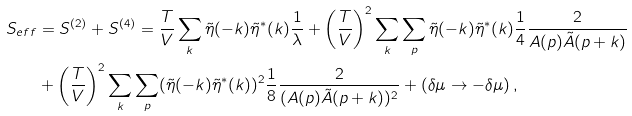Convert formula to latex. <formula><loc_0><loc_0><loc_500><loc_500>S _ { e f f } & = S ^ { ( 2 ) } + S ^ { ( 4 ) } = \frac { T } { V } \sum _ { k } \tilde { \eta } ( - k ) \tilde { \eta } ^ { * } ( k ) \frac { 1 } { \lambda } + \left ( \frac { T } { V } \right ) ^ { 2 } \sum _ { k } \sum _ { p } \tilde { \eta } ( - k ) \tilde { \eta } ^ { * } ( k ) \frac { 1 } { 4 } \frac { 2 } { A ( p ) \tilde { A } ( p + k ) } \\ & + \left ( \frac { T } { V } \right ) ^ { 2 } \sum _ { k } \sum _ { p } ( \tilde { \eta } ( - k ) \tilde { \eta } ^ { * } ( k ) ) ^ { 2 } \frac { 1 } { 8 } \frac { 2 } { ( A ( p ) \tilde { A } ( p + k ) ) ^ { 2 } } + ( \delta \mu \rightarrow - \delta \mu ) \, ,</formula> 